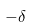Convert formula to latex. <formula><loc_0><loc_0><loc_500><loc_500>- \delta</formula> 